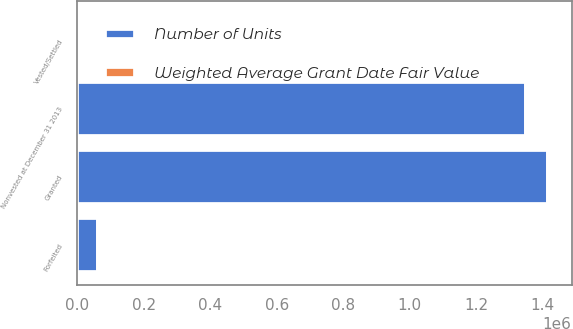Convert chart. <chart><loc_0><loc_0><loc_500><loc_500><stacked_bar_chart><ecel><fcel>Granted<fcel>Vested/Settled<fcel>Forfeited<fcel>Nonvested at December 31 2013<nl><fcel>Number of Units<fcel>1.41654e+06<fcel>1844<fcel>63127<fcel>1.35157e+06<nl><fcel>Weighted Average Grant Date Fair Value<fcel>17.03<fcel>17<fcel>17.01<fcel>17.04<nl></chart> 